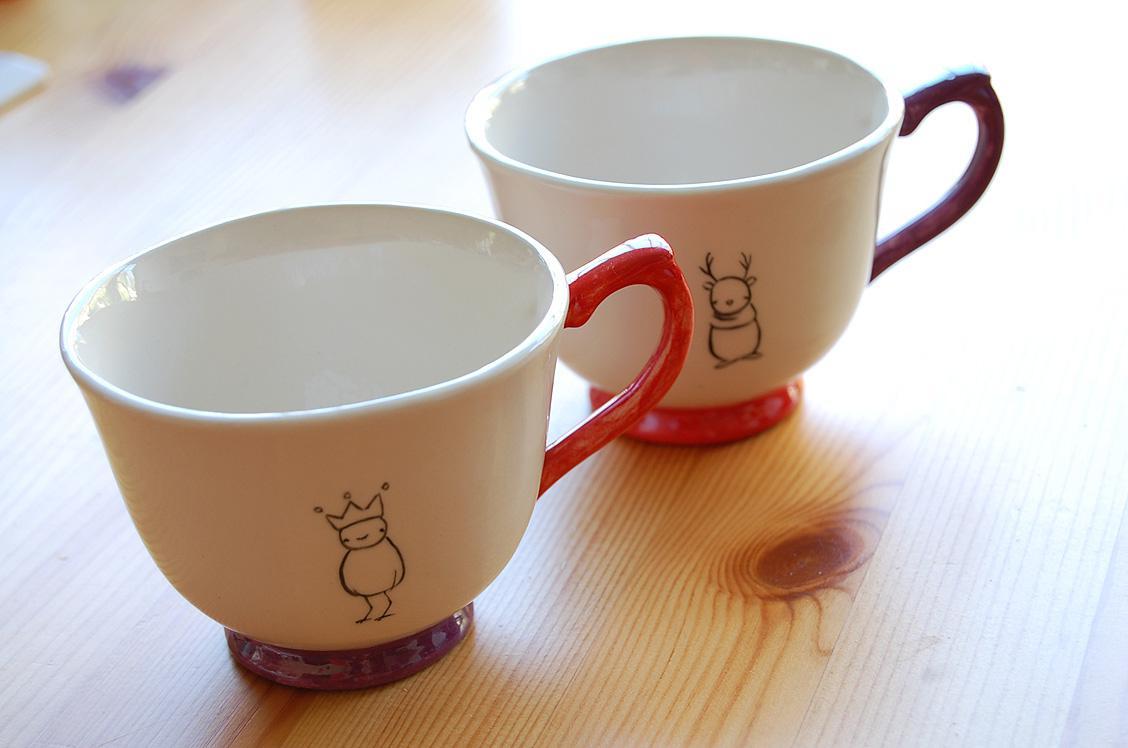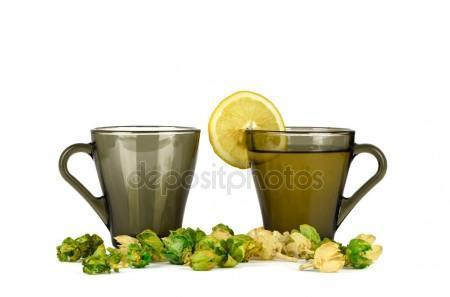The first image is the image on the left, the second image is the image on the right. Considering the images on both sides, is "Each image shows two side-by-side cups." valid? Answer yes or no. Yes. The first image is the image on the left, the second image is the image on the right. Given the left and right images, does the statement "At least one white cup sits in a white saucer." hold true? Answer yes or no. No. 